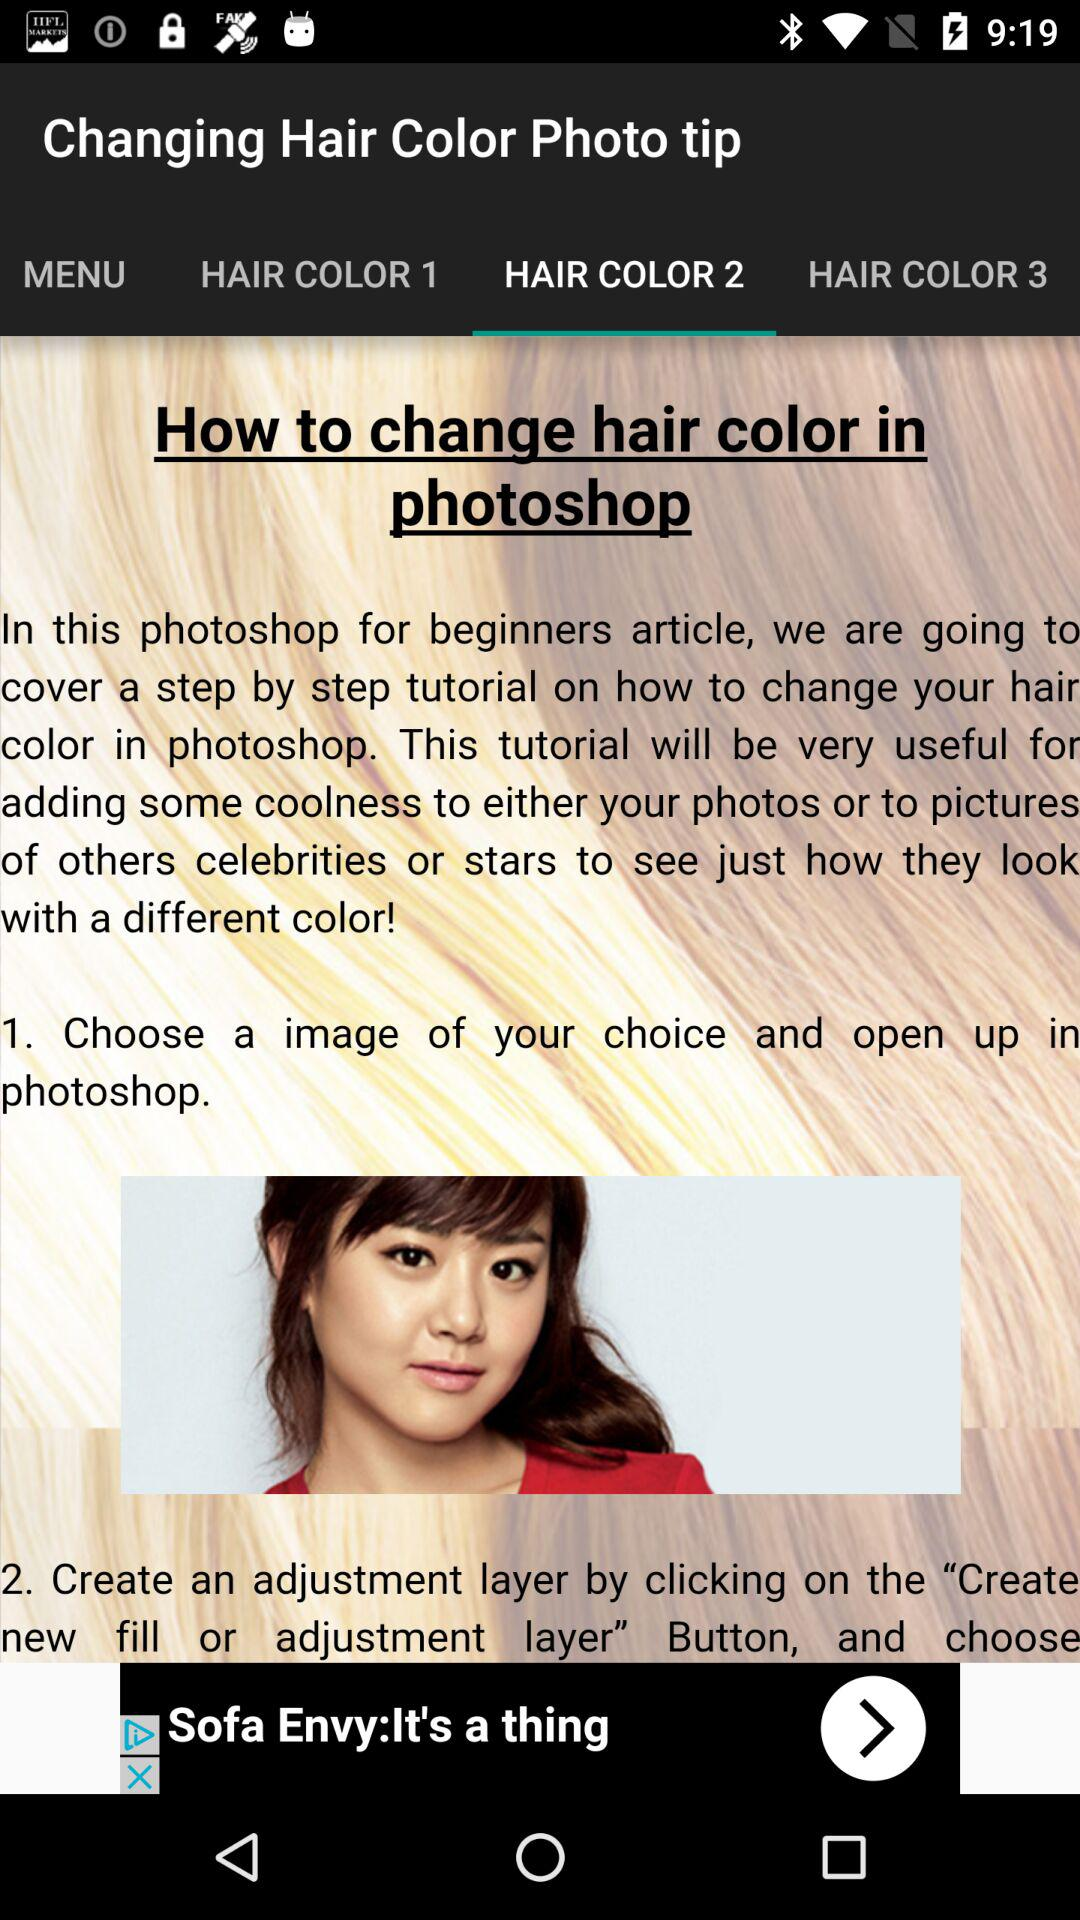Which tab are we currently on? You are currently on "HAIR COLOR 2" tab. 